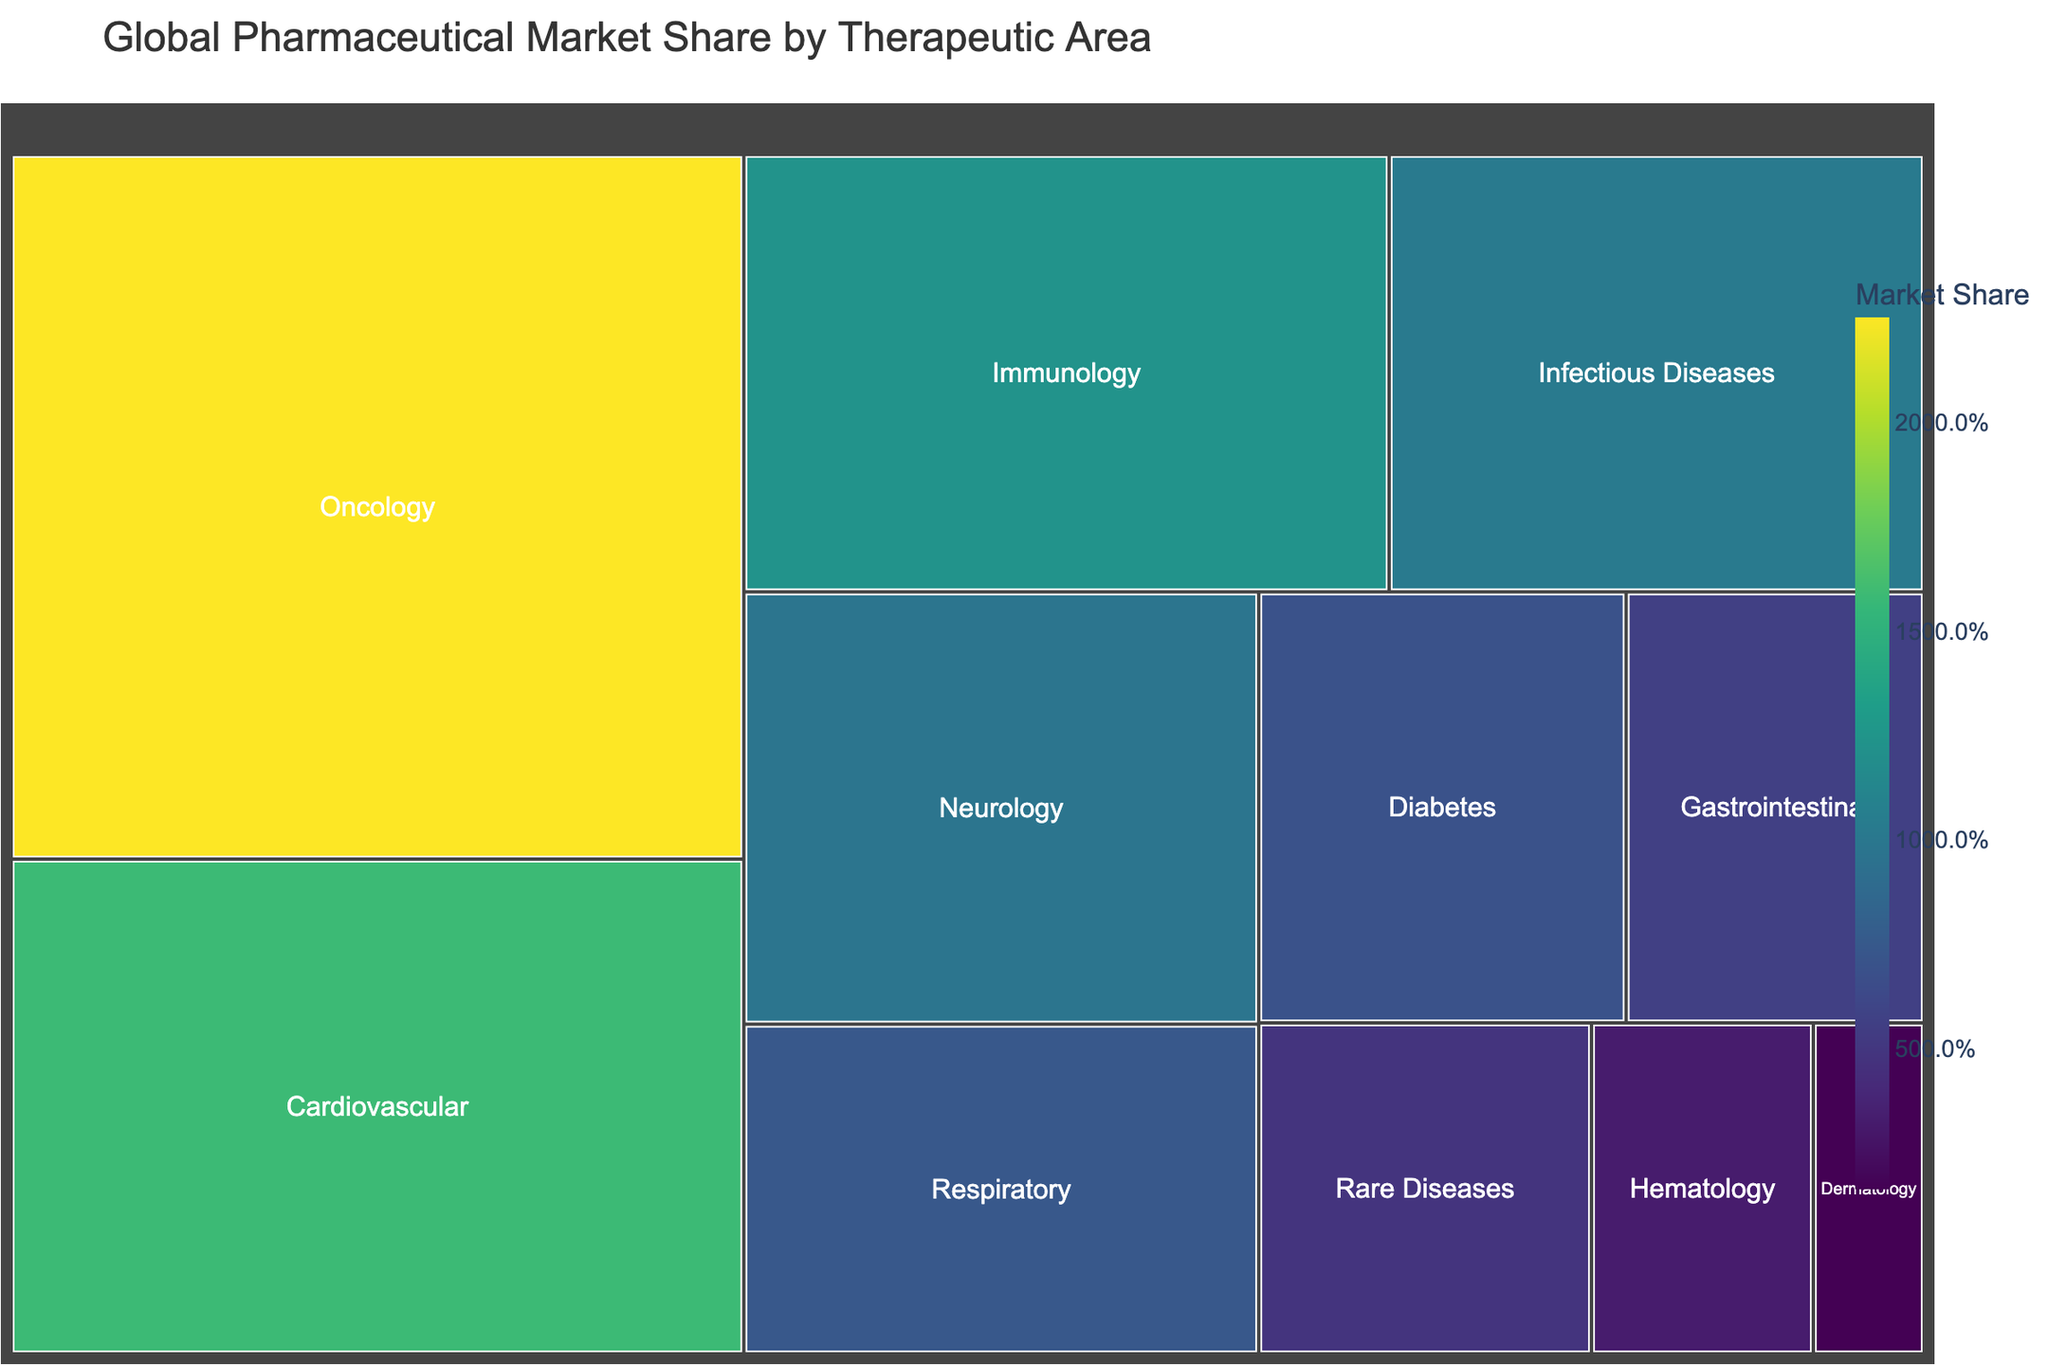Which therapeutic area has the highest market share? The therapeutic area with the highest market share is indicated by the largest section in the treemap. According to the data, Oncology has the highest market share.
Answer: Oncology What is the combined market share of Cardiovascular and Immunology therapeutic areas? To find the combined market share, add the market shares of Cardiovascular (15.8%) and Immunology (12.3%). 15.8 + 12.3 = 28.1%.
Answer: 28.1% How does the market share of Neurology compare to that of Respiratory? To compare market shares, refer to their values. Neurology has 9.7% and Respiratory has 7.4%. 9.7 is greater than 7.4.
Answer: Neurology has a greater market share Which therapeutic area has the smallest market share? The therapeutic area with the smallest market share is indicated by the smallest section in the treemap. According to the data, Dermatology has the smallest market share.
Answer: Dermatology What is the total market share of therapeutic areas with less than 10% market share each? To find the total, sum the market shares of areas with less than 10% market share each: Infectious Diseases (10.2% not included), Neurology (9.7%), Respiratory (7.4%), Diabetes (6.9%), Gastrointestinal (5.6%), Rare Diseases (4.8%), Hematology (3.2%), and Dermatology (1.6%). 9.7 + 7.4 + 6.9 + 5.6 + 4.8 + 3.2 + 1.6 = 39.2%.
Answer: 39.2% Which therapeutic areas have a market share greater than 5% but less than 10%? To find these areas, look at the data: Neurology (9.7%), Respiratory (7.4%), Diabetes (6.9%), and Gastrointestinal (5.6%) all meet the criteria.
Answer: Neurology, Respiratory, Diabetes, Gastrointestinal What is the difference in market share between Oncology and Cardiovascular? Subtract Cardiovascular’s market share (15.8%) from Oncology’s (22.5%): 22.5 - 15.8 = 6.7%.
Answer: 6.7% Are there more therapeutic areas with market shares above or below 10%? Count the therapeutic areas with market shares above and below 10%. Above 10%: Oncology, Cardiovascular, Immunology (3). Below 10%: Infectious Diseases, Neurology, Respiratory, Diabetes, Gastrointestinal, Rare Diseases, Hematology, Dermatology (8). There are more areas below 10%.
Answer: Below 10% If the market share of Hematology doubled, what would its new market share be? Doubling the market share of Hematology (3.2%) involves multiplying by 2: 3.2 * 2 = 6.4%.
Answer: 6.4% 